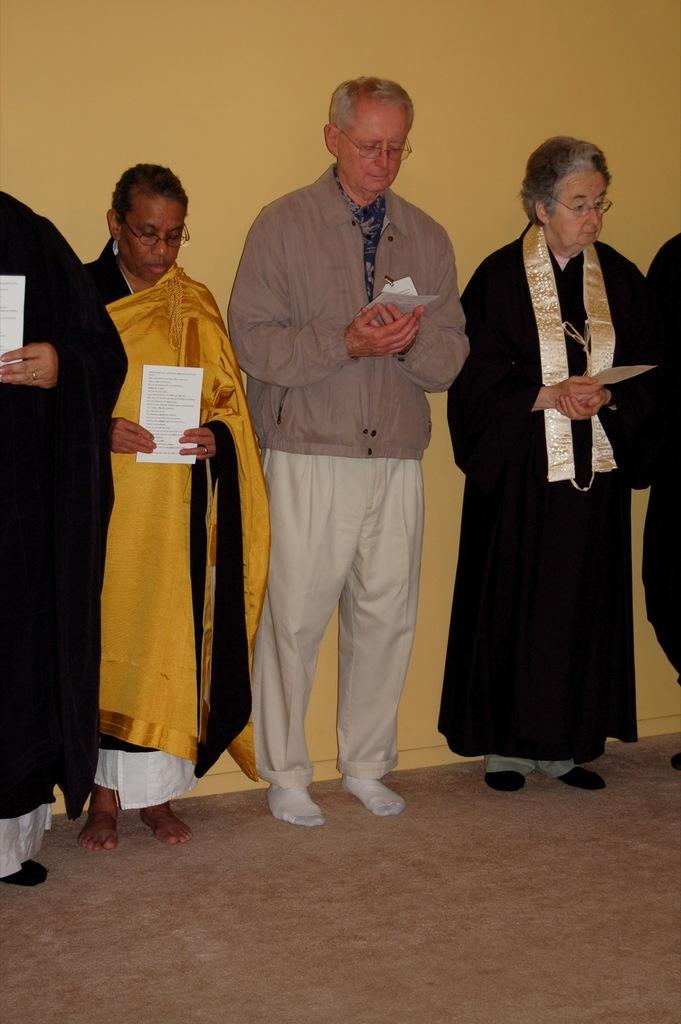What are the people in the image doing? The people in the image are standing in the middle of the image. What are the people holding in the image? The people are holding papers in the image. What can be seen in the background of the image? There is a wall visible in the background of the image. What type of blade is being used by the people in the image? There is no blade present in the image; the people are holding papers. How many clovers can be seen growing on the wall in the image? There are no clovers visible in the image, as the wall is the only background element mentioned. 